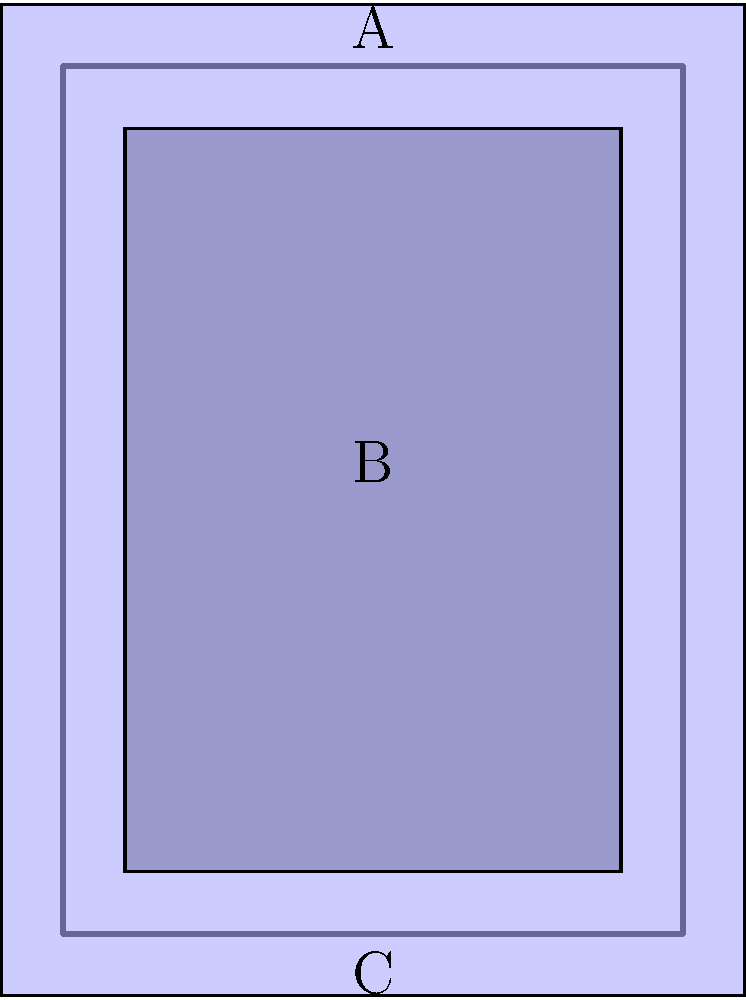In the layered clothing diagram above, which item should be put on first to achieve the correct layering effect? To determine the correct order of layering clothing items, we need to analyze the diagram from the innermost layer to the outermost layer:

1. The largest and lightest-colored rectangle represents the base layer, which is typically a shirt. This should be put on first as it's closest to the body.

2. The middle-sized rectangle with a slightly darker shade represents the middle layer, which could be a vest. This would go over the shirt.

3. The outermost layer, drawn with a dark outline, represents a jacket or outer layer. This would be put on last.

The labels in the diagram correspond to these layers:
A - Outermost layer (jacket)
B - Middle layer (vest)
C - Base layer (shirt)

To achieve the correct layering effect, we must start with the innermost layer and work our way outward. Therefore, the item labeled C (the shirt) should be put on first.
Answer: C 